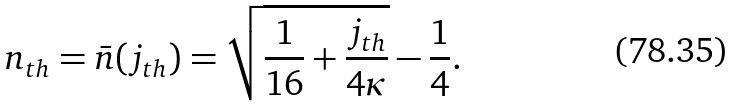<formula> <loc_0><loc_0><loc_500><loc_500>n _ { t h } = \bar { n } ( j _ { t h } ) = \sqrt { \frac { 1 } { 1 6 } + \frac { j _ { t h } } { 4 \kappa } } - \frac { 1 } { 4 } .</formula> 